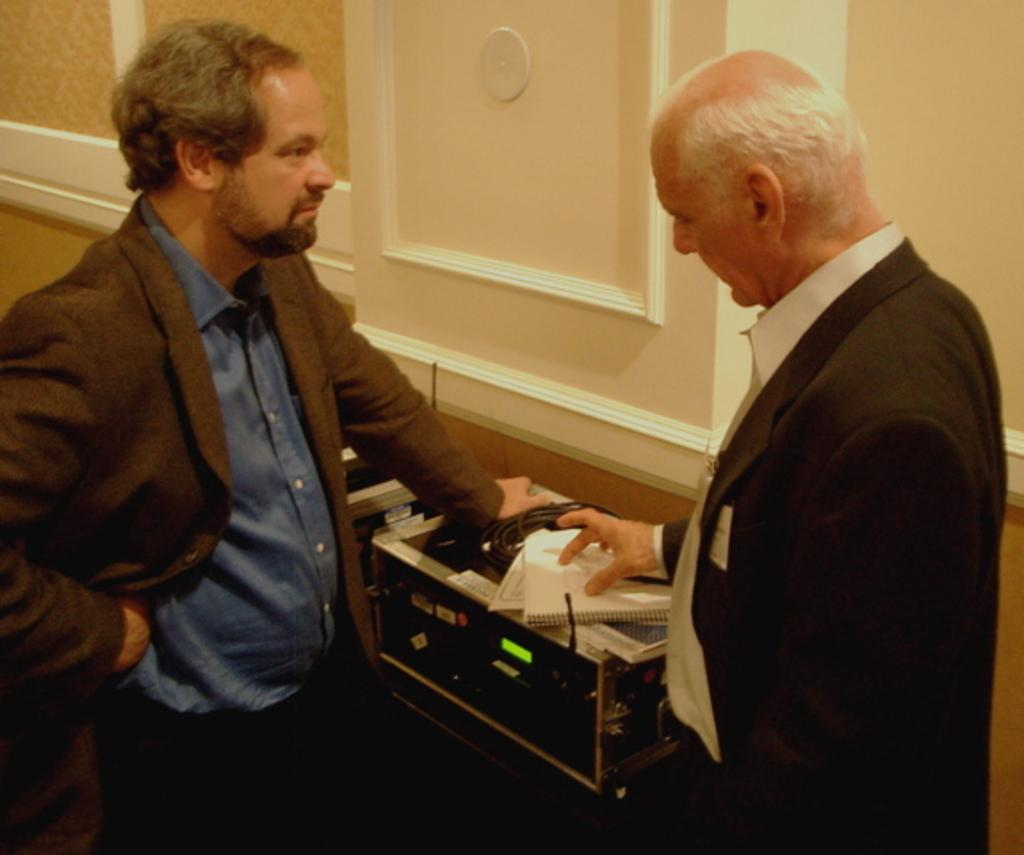How many people are in the image? There are two men standing in the image. What is separating the two men? There is a table between the two men. What is on the table? A box is placed on the table, along with books and other objects. What can be seen in the background of the image? There is a wall in the background of the image. Can you see the queen standing next to the men in the image? No, there is no queen present in the image. Are there any icicles hanging from the wall in the background? No, there are no icicles visible in the image. 